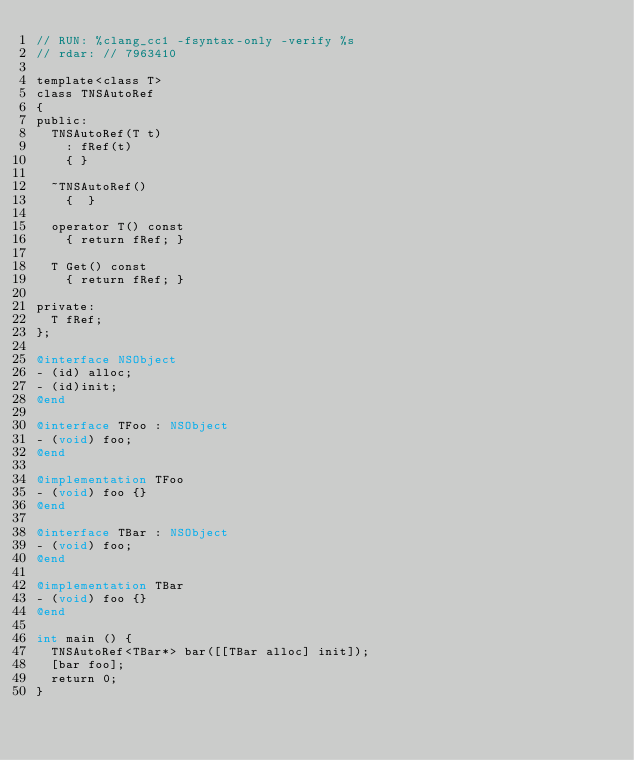<code> <loc_0><loc_0><loc_500><loc_500><_ObjectiveC_>// RUN: %clang_cc1 -fsyntax-only -verify %s
// rdar: // 7963410

template<class T>
class TNSAutoRef
{
public:
	TNSAutoRef(T t)
		:	fRef(t)
		{ }

	~TNSAutoRef()
		{  }

	operator T() const
		{ return fRef; }
	
	T Get() const
		{ return fRef; }

private:
	T fRef;
};

@interface NSObject
- (id) alloc;
- (id)init;
@end

@interface TFoo : NSObject
- (void) foo;
@end

@implementation TFoo
- (void) foo {}
@end

@interface TBar : NSObject
- (void) foo;
@end

@implementation TBar 
- (void) foo {}
@end

int main () {
	TNSAutoRef<TBar*> bar([[TBar alloc] init]);
	[bar foo];
	return 0;
}
</code> 